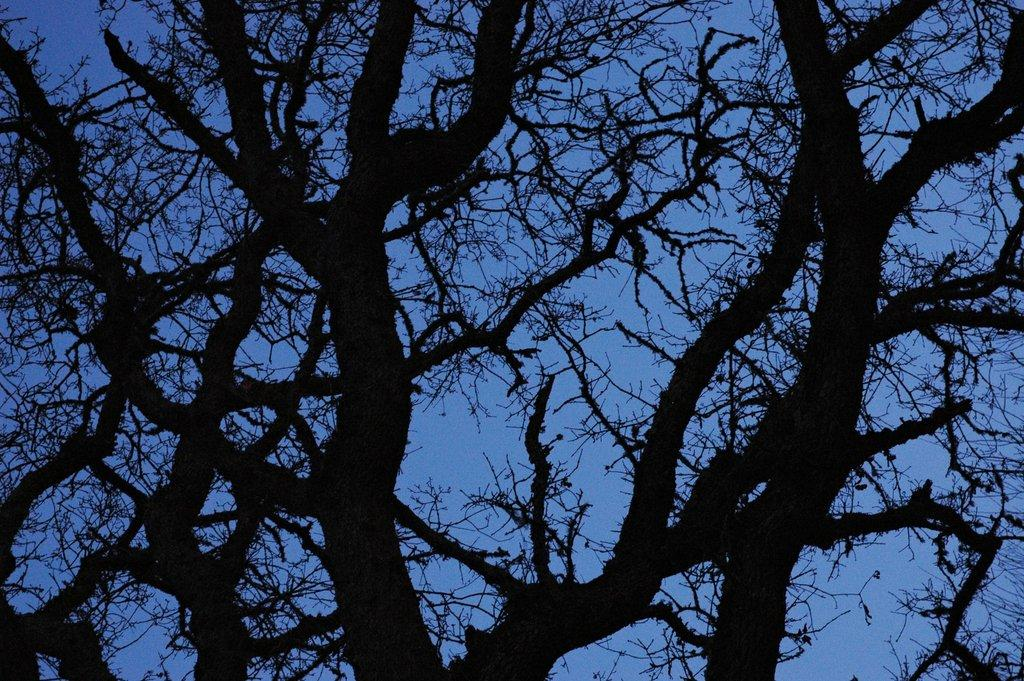What is the main object in the image? There is a tree in the image. What can be seen in the background of the image? The sky is visible in the background of the image. How many chickens are perched on the horn in the image? There are no chickens or horns present in the image; it features a tree and the sky. 